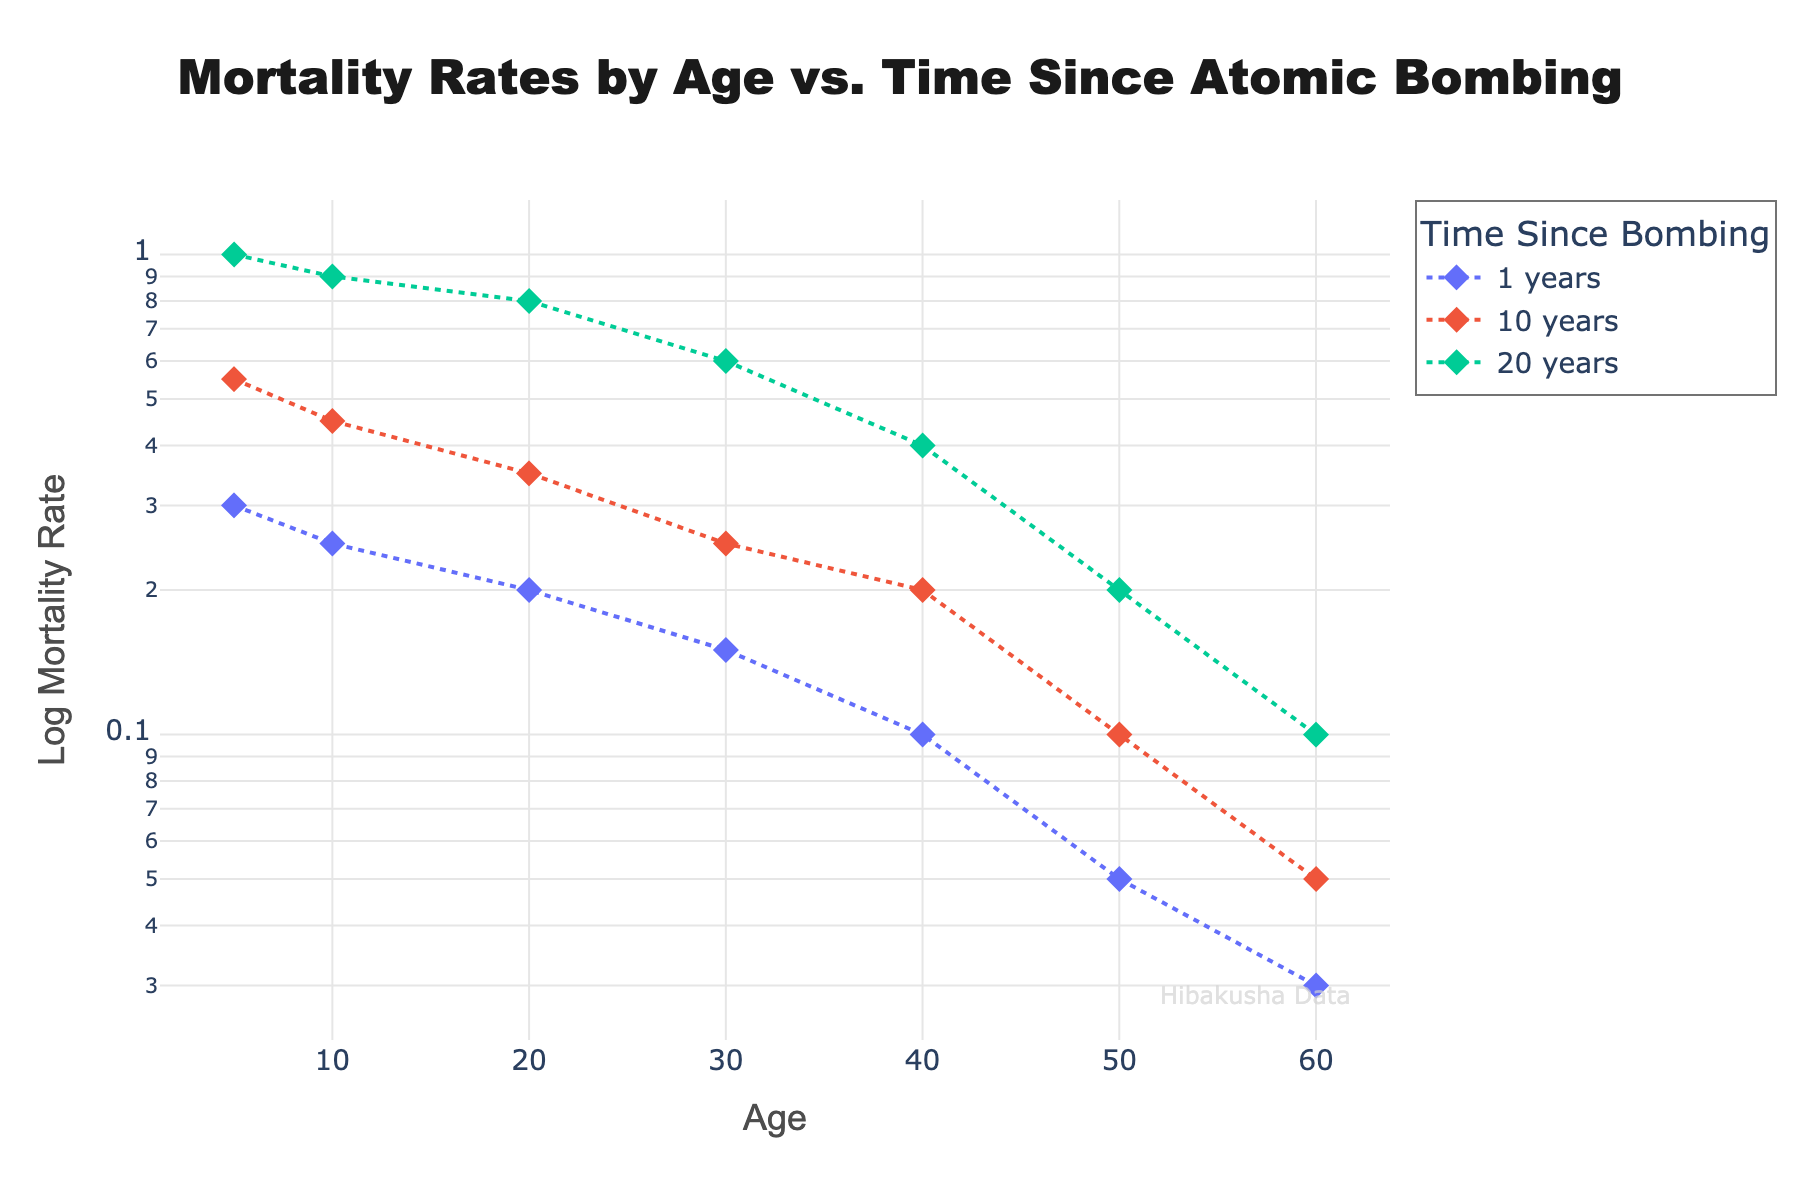What is the title of the plot? The title of the plot is prominently displayed at the top of the figure. It reads "Mortality Rates by Age vs. Time Since Atomic Bombing".
Answer: Mortality Rates by Age vs. Time Since Atomic Bombing What are the labels of the X and Y axes? The X-axis is labeled "Age" and the Y-axis is labeled "Log Mortality Rate". These labels describe what variables are being represented on each axis.
Answer: Age, Log Mortality Rate How does the mortality rate at age 10 compare between 1 year and 20 years after the bombing? At 1 year after the bombing, the log mortality rate for age 10 is 0.25. At 20 years after the bombing, the log mortality rate for age 10 is 0.9. Therefore, the mortality rate is higher at 20 years after the bombing.
Answer: Higher at 20 years Which age group shows the highest mortality rate 20 years after the bombing? By examining the points 20 years after the bombing, the age group with the highest log mortality rate is age 5, with a log mortality rate of 1.0.
Answer: Age 5 Which age group shows the lowest mortality rate 1 year after the bombing? The data point 1 year after the bombing that shows the lowest log mortality rate is for age 60, with a log mortality rate of 0.03.
Answer: Age 60 What general trend do you observe in mortality rates as time since the bombing increases? Observing the plot, the log mortality rates tend to increase as the time since the bombing increases across almost all age groups, with the rate being the highest at 20 years after the bombing.
Answer: Increase Which age group shows the most significant increase in mortality rate between 1 year and 20 years after the bombing? Looking at the difference in log mortality rates for each age group between 1 year and 20 years after the bombing, the age group 5 shows the most significant increase, from 0.3 to 1.0. The increase is 0.7.
Answer: Age 5 What does the log scale on the Y-axis tell us about the data, and why is it useful here? The log scale on the Y-axis shows the data in logarithmic form, which helps in visualizing changes over several orders of magnitude. It is useful here because mortality rates can span a wide range of values and the log scale helps in understanding relative differences more clearly.
Answer: Log scale emphasizes changes across magnitudes Is the log mortality rate for age 40 significantly different between 10 years and 20 years after the bombing? For age 40, the log mortality rate is 0.2 at 10 years and 0.4 at 20 years after the bombing. While this is an increase, it is not as pronounced as for other age groups.
Answer: Not significantly different How many time-points are shown for each age group in the plot? Each age group in the plot has 3 time-points represented: 1 year, 10 years, and 20 years since the bombing.
Answer: 3 time-points per age group 